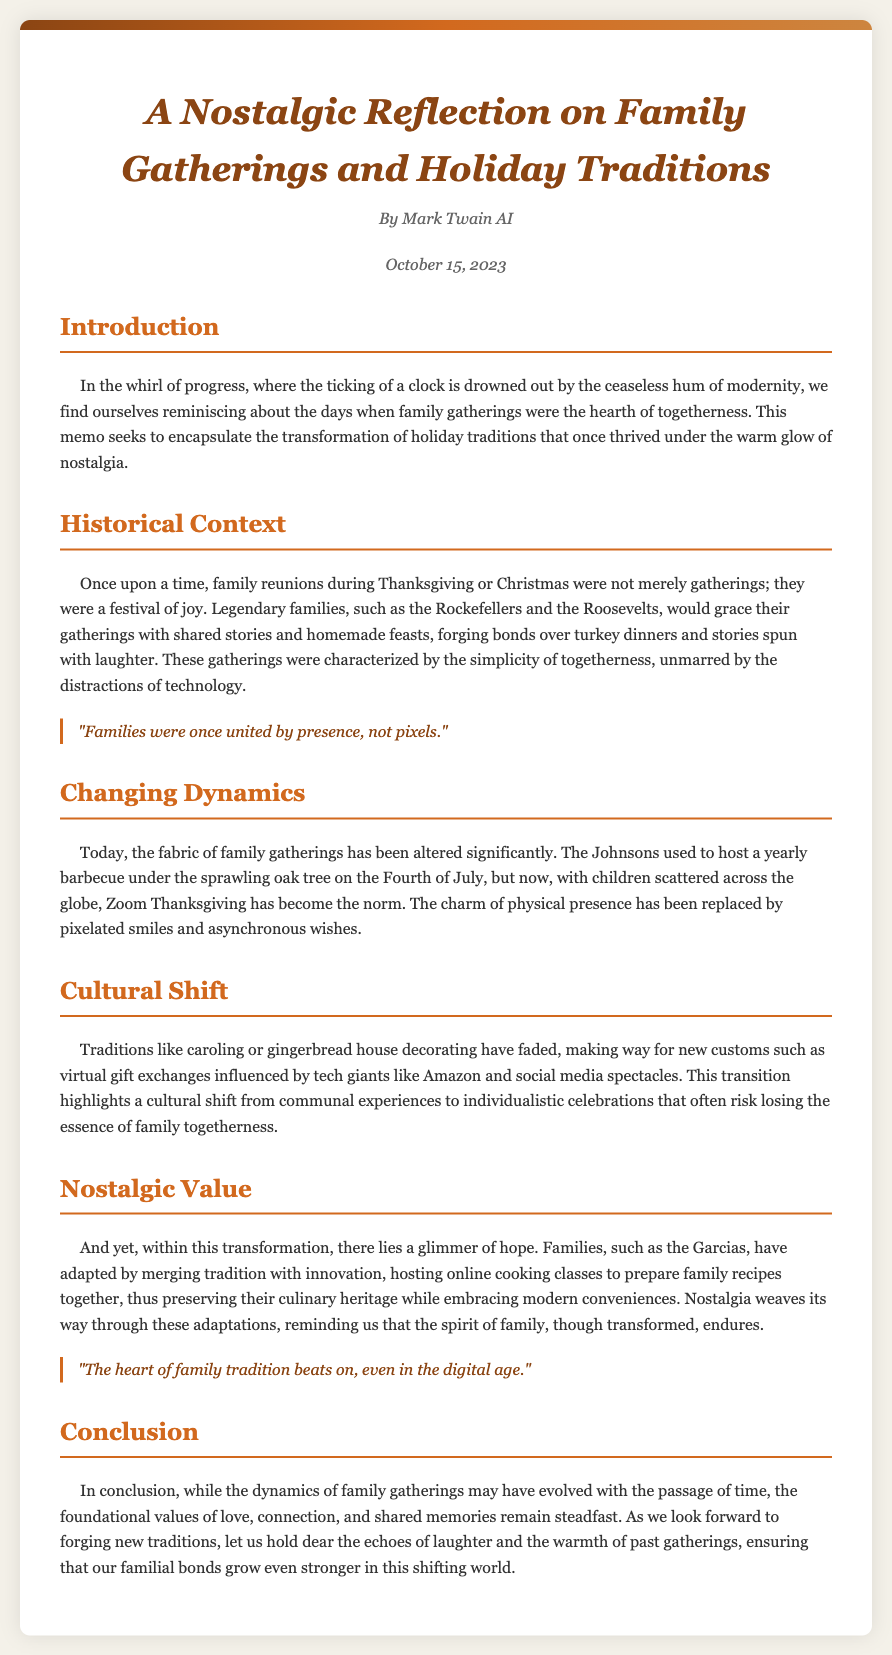What is the title of the document? The title of the document is presented prominently at the beginning of the memo.
Answer: A Nostalgic Reflection on Family Gatherings and Holiday Traditions Who is the author of the memo? The author is mentioned in the author section beneath the title.
Answer: Mark Twain AI When was the memo published? The publication date is indicated near the author's name.
Answer: October 15, 2023 What was a traditional family gathering during holidays characterized by? The document outlines the characteristics of past family gatherings in its historical context section.
Answer: Simplicity of togetherness What is one example of how modern family gatherings have changed? The changing dynamics section describes one specific change to modern gatherings.
Answer: Zoom Thanksgiving What cultural shift does the memo mention? The text discusses a transition within family traditions in the cultural shift section.
Answer: Virtual gift exchanges What hope does the author express about family traditions? The nostalgic value section indicates a glimmer of hope for family traditions.
Answer: Spirit of family What is the primary message of the conclusion? The conclusion summarizes the enduring values that remain.
Answer: Love, connection, and shared memories What aspect of family tradition does the first quote highlight? The first quote addresses a specific aspect related to family presence.
Answer: Family unity 